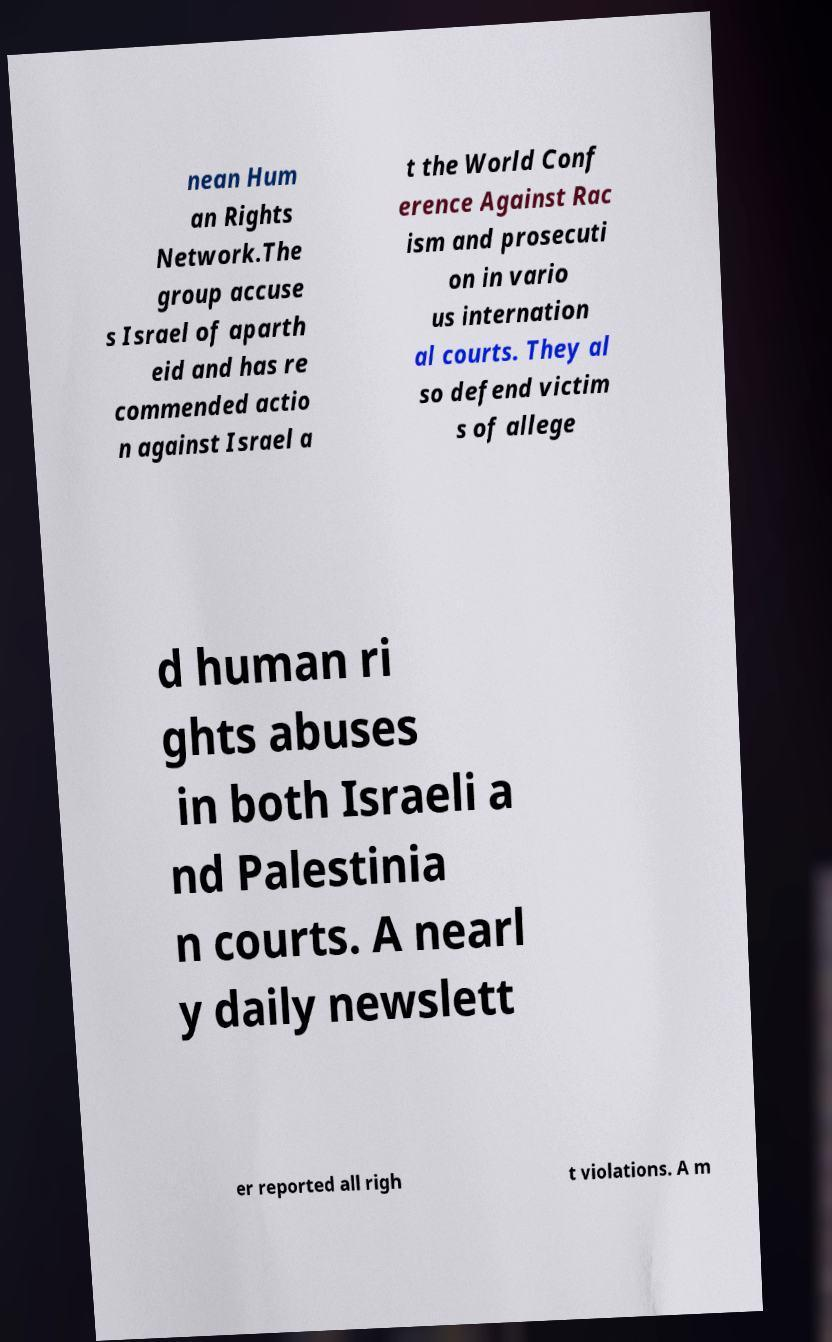I need the written content from this picture converted into text. Can you do that? nean Hum an Rights Network.The group accuse s Israel of aparth eid and has re commended actio n against Israel a t the World Conf erence Against Rac ism and prosecuti on in vario us internation al courts. They al so defend victim s of allege d human ri ghts abuses in both Israeli a nd Palestinia n courts. A nearl y daily newslett er reported all righ t violations. A m 